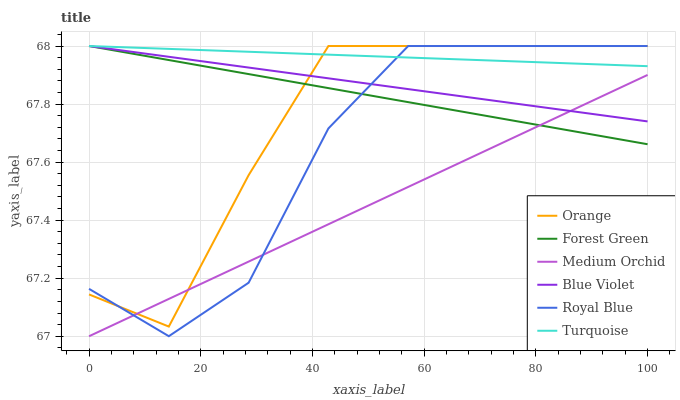Does Medium Orchid have the minimum area under the curve?
Answer yes or no. Yes. Does Turquoise have the maximum area under the curve?
Answer yes or no. Yes. Does Royal Blue have the minimum area under the curve?
Answer yes or no. No. Does Royal Blue have the maximum area under the curve?
Answer yes or no. No. Is Blue Violet the smoothest?
Answer yes or no. Yes. Is Royal Blue the roughest?
Answer yes or no. Yes. Is Medium Orchid the smoothest?
Answer yes or no. No. Is Medium Orchid the roughest?
Answer yes or no. No. Does Medium Orchid have the lowest value?
Answer yes or no. Yes. Does Royal Blue have the lowest value?
Answer yes or no. No. Does Blue Violet have the highest value?
Answer yes or no. Yes. Does Medium Orchid have the highest value?
Answer yes or no. No. Is Medium Orchid less than Turquoise?
Answer yes or no. Yes. Is Turquoise greater than Medium Orchid?
Answer yes or no. Yes. Does Medium Orchid intersect Royal Blue?
Answer yes or no. Yes. Is Medium Orchid less than Royal Blue?
Answer yes or no. No. Is Medium Orchid greater than Royal Blue?
Answer yes or no. No. Does Medium Orchid intersect Turquoise?
Answer yes or no. No. 